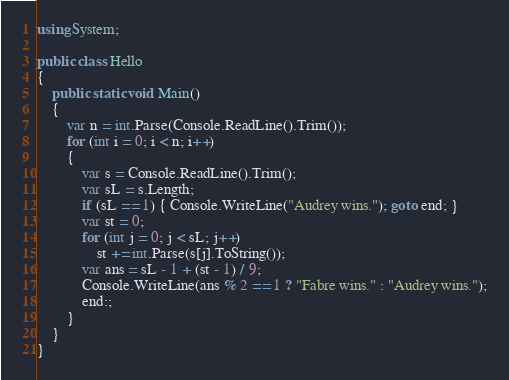Convert code to text. <code><loc_0><loc_0><loc_500><loc_500><_C#_>using System;

public class Hello
{
    public static void Main()
    {
        var n = int.Parse(Console.ReadLine().Trim());
        for (int i = 0; i < n; i++)
        {
            var s = Console.ReadLine().Trim();
            var sL = s.Length;
            if (sL == 1) { Console.WriteLine("Audrey wins."); goto end; }
            var st = 0;
            for (int j = 0; j < sL; j++)
                st += int.Parse(s[j].ToString());
            var ans = sL - 1 + (st - 1) / 9;
            Console.WriteLine(ans % 2 == 1 ? "Fabre wins." : "Audrey wins.");
            end:;
        }
    }
}
</code> 